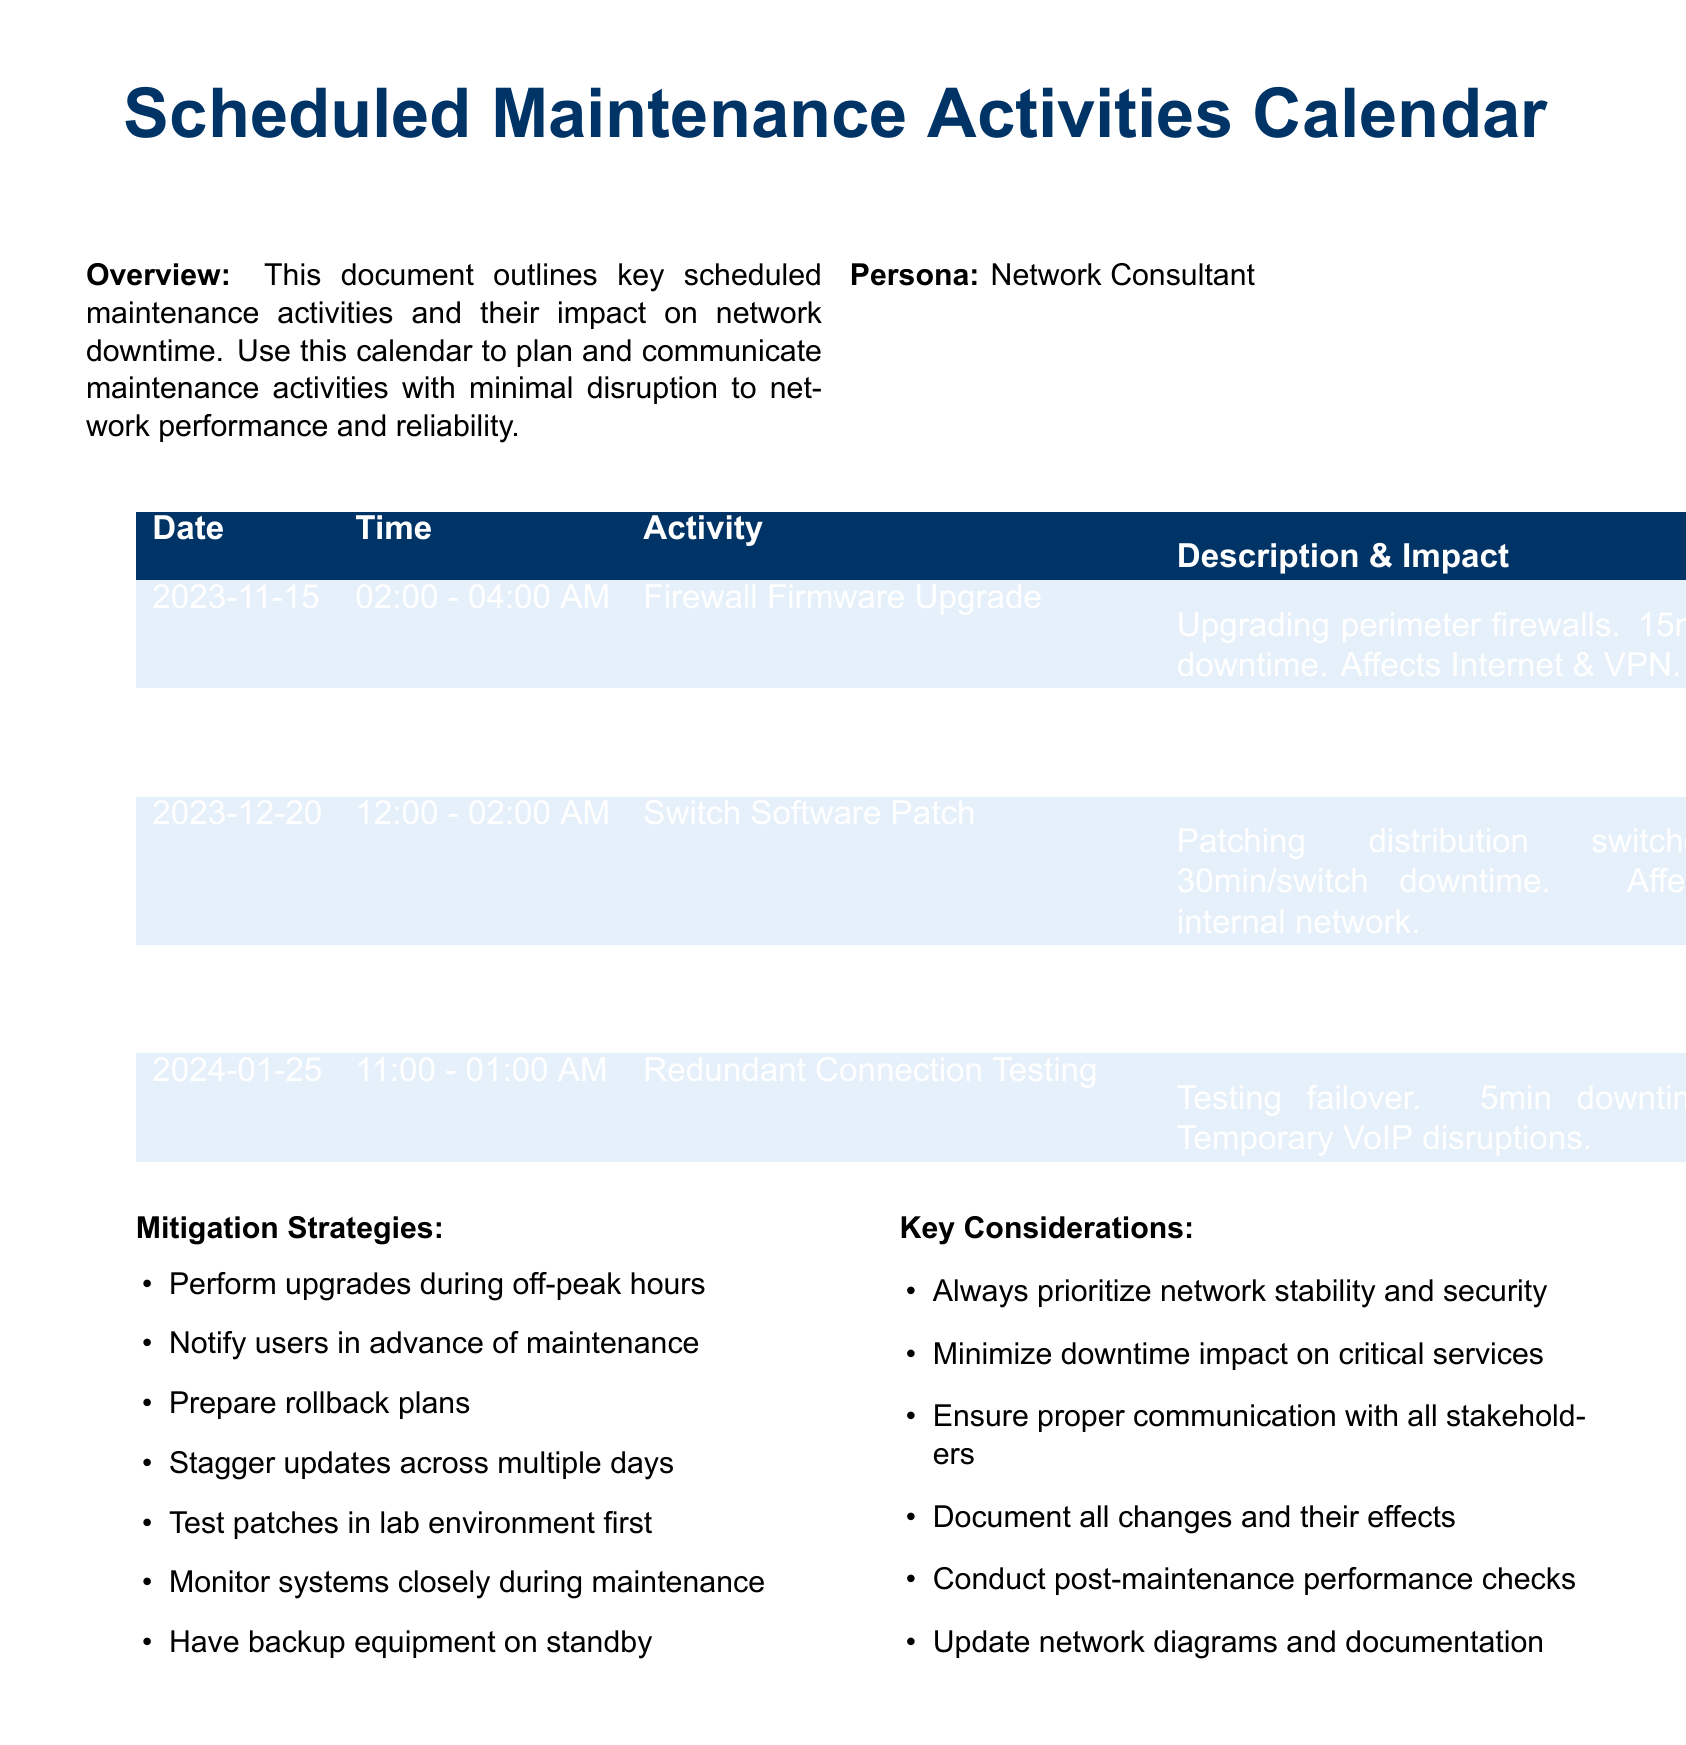What is the first scheduled maintenance activity? The first maintenance activity listed in the document is the Firewall Firmware Upgrade on November 15, 2023.
Answer: Firewall Firmware Upgrade What is the total downtime for the Core Router Replacement? The Core Router Replacement is scheduled for 2 hours of downtime according to the document.
Answer: 2hr What is the date of the Switch Software Patch activity? The Switch Software Patch activity is scheduled for December 20, 2023, as indicated in the calendar.
Answer: December 20, 2023 How long is the downtime for redundant connection testing? The downtime for redundant connection testing is specifically noted as 5 minutes.
Answer: 5min Which maintenance activity has no associated downtime? The Data Center Cooling Maintenance explicitly states that there is no downtime expected.
Answer: Data Center Cooling Maintenance What activity is scheduled for January 25, 2024? The activity scheduled for January 25, 2024, is Redundant Connection Testing.
Answer: Redundant Connection Testing What is one of the mitigation strategies listed in the document? The document lists several strategies, one of which is to perform upgrades during off-peak hours.
Answer: Perform upgrades during off-peak hours What is an impact of the Switch Software Patch? The impact of the Switch Software Patch is a 30-minute downtime per switch affecting the internal network.
Answer: 30min downtime What should be prepared in advance according to the mitigation strategies? The document suggests to prepare rollback plans in advance of the maintenance activities.
Answer: Rollback plans 